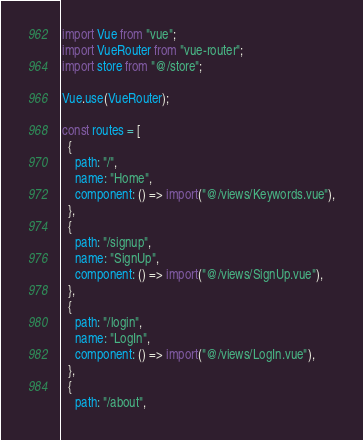<code> <loc_0><loc_0><loc_500><loc_500><_JavaScript_>import Vue from "vue";
import VueRouter from "vue-router";
import store from "@/store";

Vue.use(VueRouter);

const routes = [
  {
    path: "/",
    name: "Home",
    component: () => import("@/views/Keywords.vue"),
  },
  {
    path: "/signup",
    name: "SignUp",
    component: () => import("@/views/SignUp.vue"),
  },
  {
    path: "/login",
    name: "LogIn",
    component: () => import("@/views/LogIn.vue"),
  },
  {
    path: "/about",</code> 